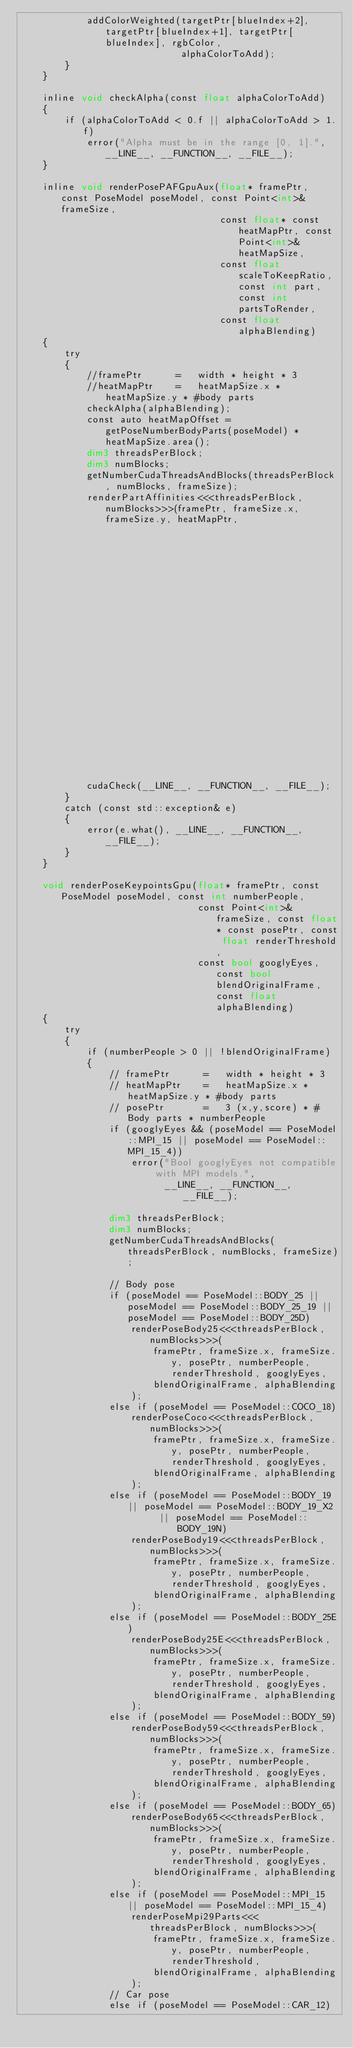<code> <loc_0><loc_0><loc_500><loc_500><_Cuda_>            addColorWeighted(targetPtr[blueIndex+2], targetPtr[blueIndex+1], targetPtr[blueIndex], rgbColor,
                             alphaColorToAdd);
        }
    }

    inline void checkAlpha(const float alphaColorToAdd)
    {
        if (alphaColorToAdd < 0.f || alphaColorToAdd > 1.f)
            error("Alpha must be in the range [0, 1].", __LINE__, __FUNCTION__, __FILE__);
    }

    inline void renderPosePAFGpuAux(float* framePtr, const PoseModel poseModel, const Point<int>& frameSize,
                                    const float* const heatMapPtr, const Point<int>& heatMapSize,
                                    const float scaleToKeepRatio, const int part, const int partsToRender,
                                    const float alphaBlending)
    {
        try
        {
            //framePtr      =   width * height * 3
            //heatMapPtr    =   heatMapSize.x * heatMapSize.y * #body parts
            checkAlpha(alphaBlending);
            const auto heatMapOffset = getPoseNumberBodyParts(poseModel) * heatMapSize.area();
            dim3 threadsPerBlock;
            dim3 numBlocks;
            getNumberCudaThreadsAndBlocks(threadsPerBlock, numBlocks, frameSize);
            renderPartAffinities<<<threadsPerBlock, numBlocks>>>(framePtr, frameSize.x, frameSize.y, heatMapPtr,
                                                                 heatMapSize.x, heatMapSize.y, scaleToKeepRatio,
                                                                 partsToRender, part, alphaBlending);
            cudaCheck(__LINE__, __FUNCTION__, __FILE__);
        }
        catch (const std::exception& e)
        {
            error(e.what(), __LINE__, __FUNCTION__, __FILE__);
        }
    }

    void renderPoseKeypointsGpu(float* framePtr, const PoseModel poseModel, const int numberPeople,
                                const Point<int>& frameSize, const float* const posePtr, const float renderThreshold,
                                const bool googlyEyes, const bool blendOriginalFrame, const float alphaBlending)
    {
        try
        {
            if (numberPeople > 0 || !blendOriginalFrame)
            {
                // framePtr      =   width * height * 3
                // heatMapPtr    =   heatMapSize.x * heatMapSize.y * #body parts
                // posePtr       =   3 (x,y,score) * #Body parts * numberPeople
                if (googlyEyes && (poseModel == PoseModel::MPI_15 || poseModel == PoseModel::MPI_15_4))
                    error("Bool googlyEyes not compatible with MPI models.",
                          __LINE__, __FUNCTION__, __FILE__);

                dim3 threadsPerBlock;
                dim3 numBlocks;
                getNumberCudaThreadsAndBlocks(threadsPerBlock, numBlocks, frameSize);

                // Body pose
                if (poseModel == PoseModel::BODY_25 || poseModel == PoseModel::BODY_25_19 || poseModel == PoseModel::BODY_25D)
                    renderPoseBody25<<<threadsPerBlock, numBlocks>>>(
                        framePtr, frameSize.x, frameSize.y, posePtr, numberPeople, renderThreshold, googlyEyes,
                        blendOriginalFrame, alphaBlending
                    );
                else if (poseModel == PoseModel::COCO_18)
                    renderPoseCoco<<<threadsPerBlock, numBlocks>>>(
                        framePtr, frameSize.x, frameSize.y, posePtr, numberPeople, renderThreshold, googlyEyes,
                        blendOriginalFrame, alphaBlending
                    );
                else if (poseModel == PoseModel::BODY_19 || poseModel == PoseModel::BODY_19_X2
                         || poseModel == PoseModel::BODY_19N)
                    renderPoseBody19<<<threadsPerBlock, numBlocks>>>(
                        framePtr, frameSize.x, frameSize.y, posePtr, numberPeople, renderThreshold, googlyEyes,
                        blendOriginalFrame, alphaBlending
                    );
                else if (poseModel == PoseModel::BODY_25E)
                    renderPoseBody25E<<<threadsPerBlock, numBlocks>>>(
                        framePtr, frameSize.x, frameSize.y, posePtr, numberPeople, renderThreshold, googlyEyes,
                        blendOriginalFrame, alphaBlending
                    );
                else if (poseModel == PoseModel::BODY_59)
                    renderPoseBody59<<<threadsPerBlock, numBlocks>>>(
                        framePtr, frameSize.x, frameSize.y, posePtr, numberPeople, renderThreshold, googlyEyes,
                        blendOriginalFrame, alphaBlending
                    );
                else if (poseModel == PoseModel::BODY_65)
                    renderPoseBody65<<<threadsPerBlock, numBlocks>>>(
                        framePtr, frameSize.x, frameSize.y, posePtr, numberPeople, renderThreshold, googlyEyes,
                        blendOriginalFrame, alphaBlending
                    );
                else if (poseModel == PoseModel::MPI_15 || poseModel == PoseModel::MPI_15_4)
                    renderPoseMpi29Parts<<<threadsPerBlock, numBlocks>>>(
                        framePtr, frameSize.x, frameSize.y, posePtr, numberPeople, renderThreshold,
                        blendOriginalFrame, alphaBlending
                    );
                // Car pose
                else if (poseModel == PoseModel::CAR_12)</code> 